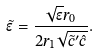Convert formula to latex. <formula><loc_0><loc_0><loc_500><loc_500>\tilde { \epsilon } = \frac { \sqrt { \epsilon } r _ { 0 } } { 2 r _ { 1 } \sqrt { \tilde { c } ^ { \prime } \hat { c } } } .</formula> 